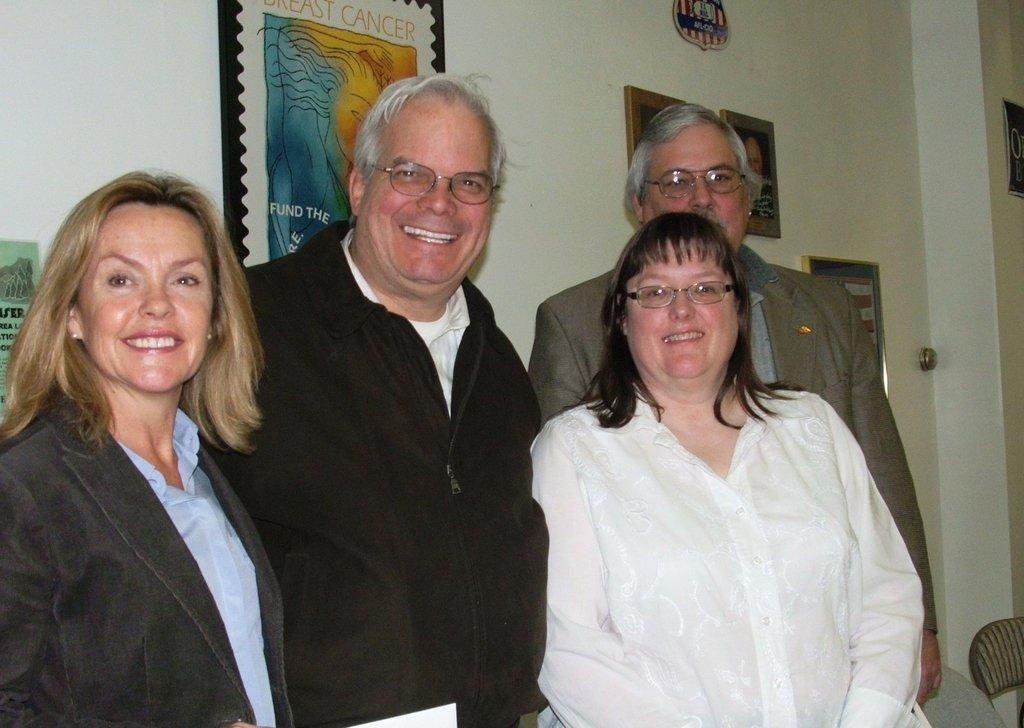How many people are present in the image? There are four people in the image. Can you describe the attire of one of the individuals? A woman is wearing a suit in the image. Where is the woman located in the image? The woman is on the left side of the image. What can be seen in the background of the image? There are photo frames in the background of the image. What type of fold can be seen in the woman's sock in the image? There is no sock visible in the image, and therefore no fold can be observed. 